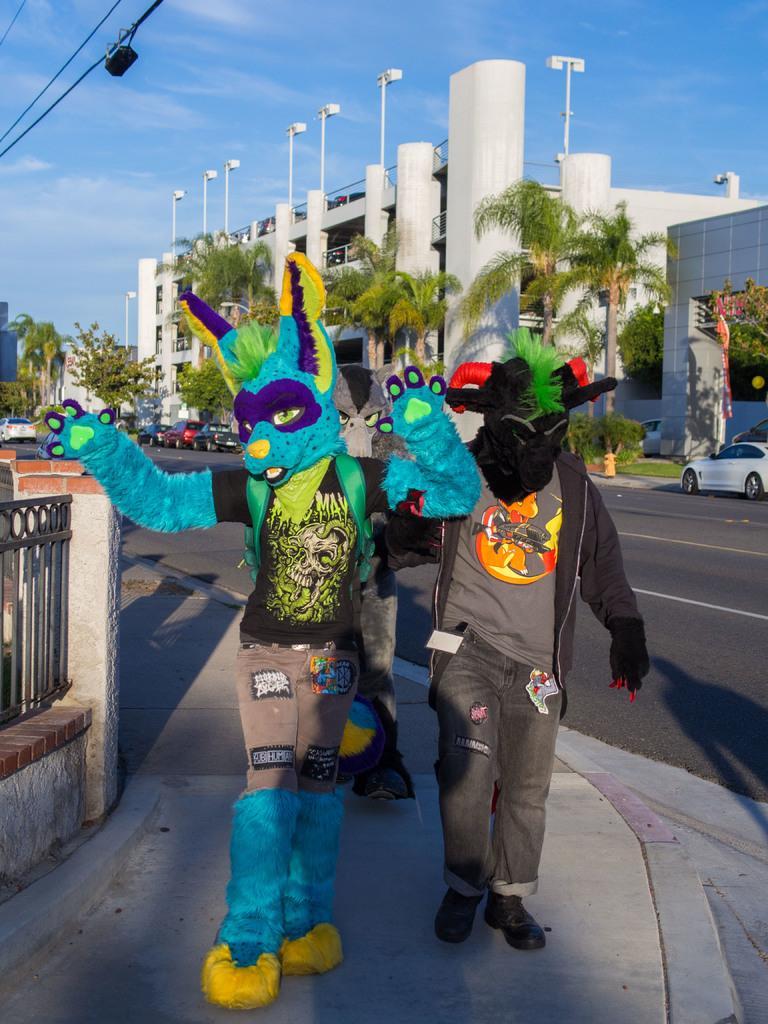Please provide a concise description of this image. In this image we can see there are people dressed up with different customs walking along the street. On the left side there is grille. In the background there are buildings, trees, plants, cars, poles and a cloudy sky. We can see there is a road. 